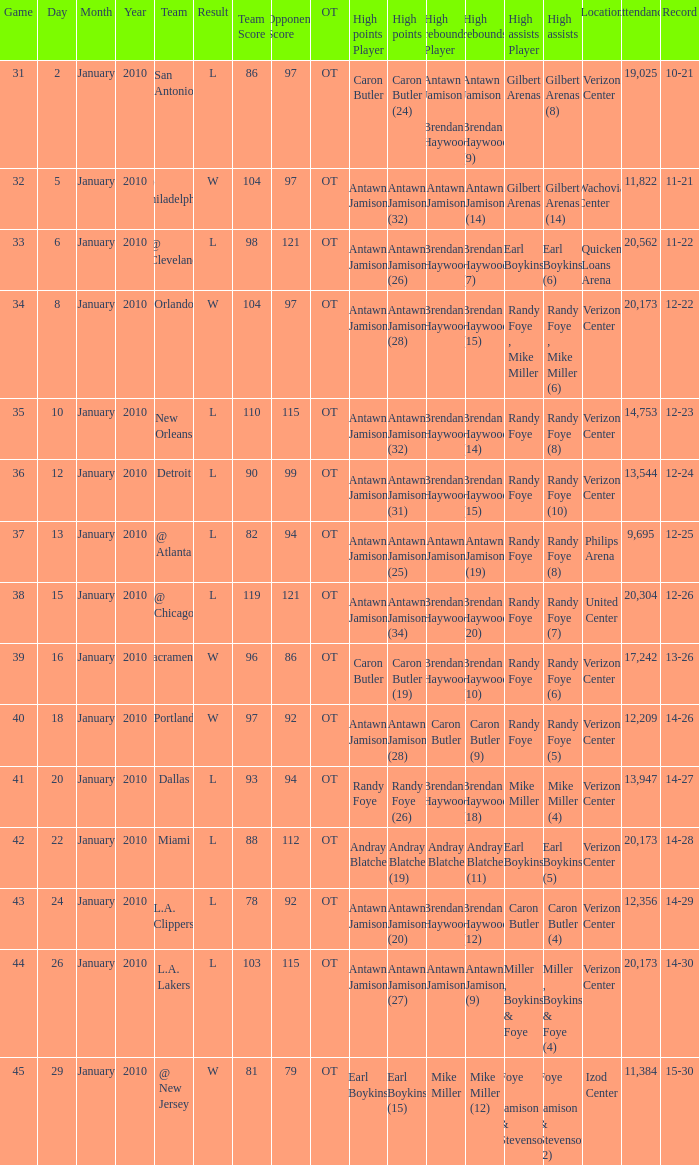What day was the record 14-27? January 20. 